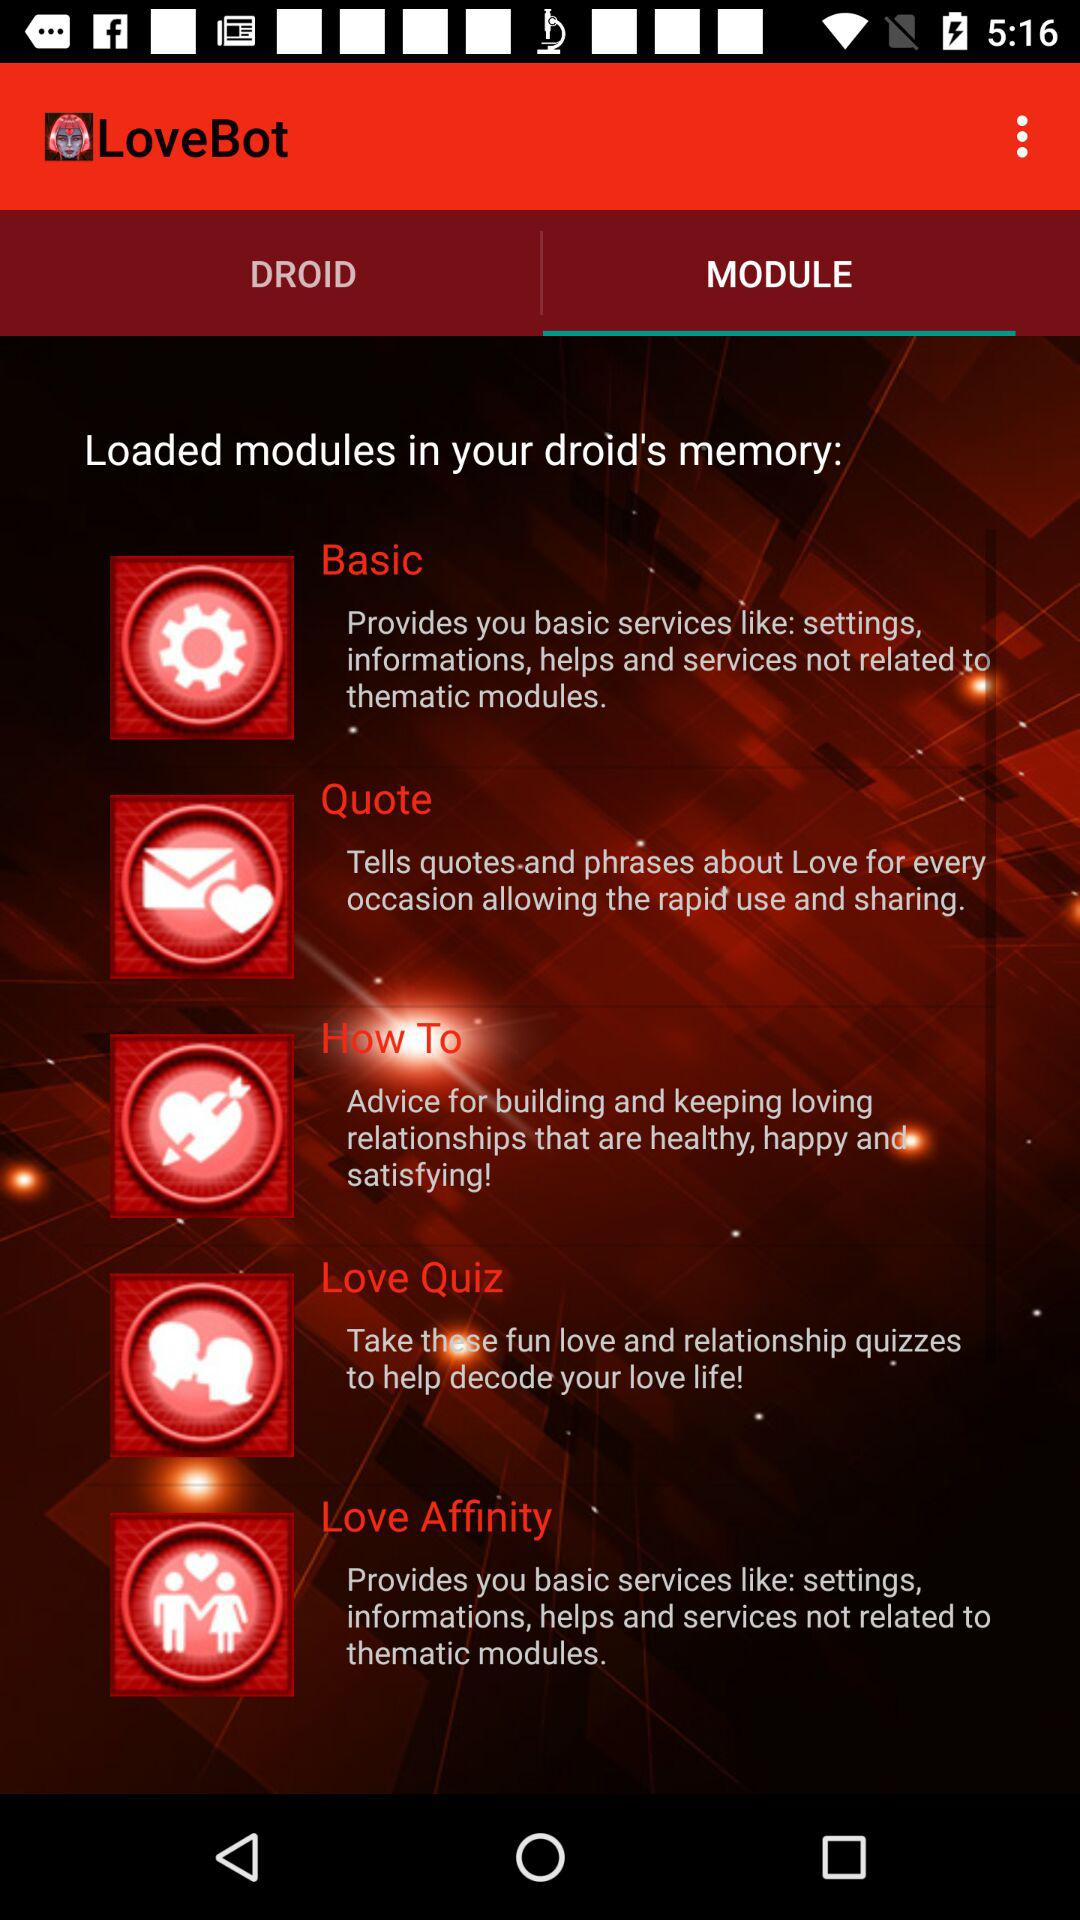Which tab is selected in "LoveBot"? The selected tab in "LoveBot" is "MODULE". 